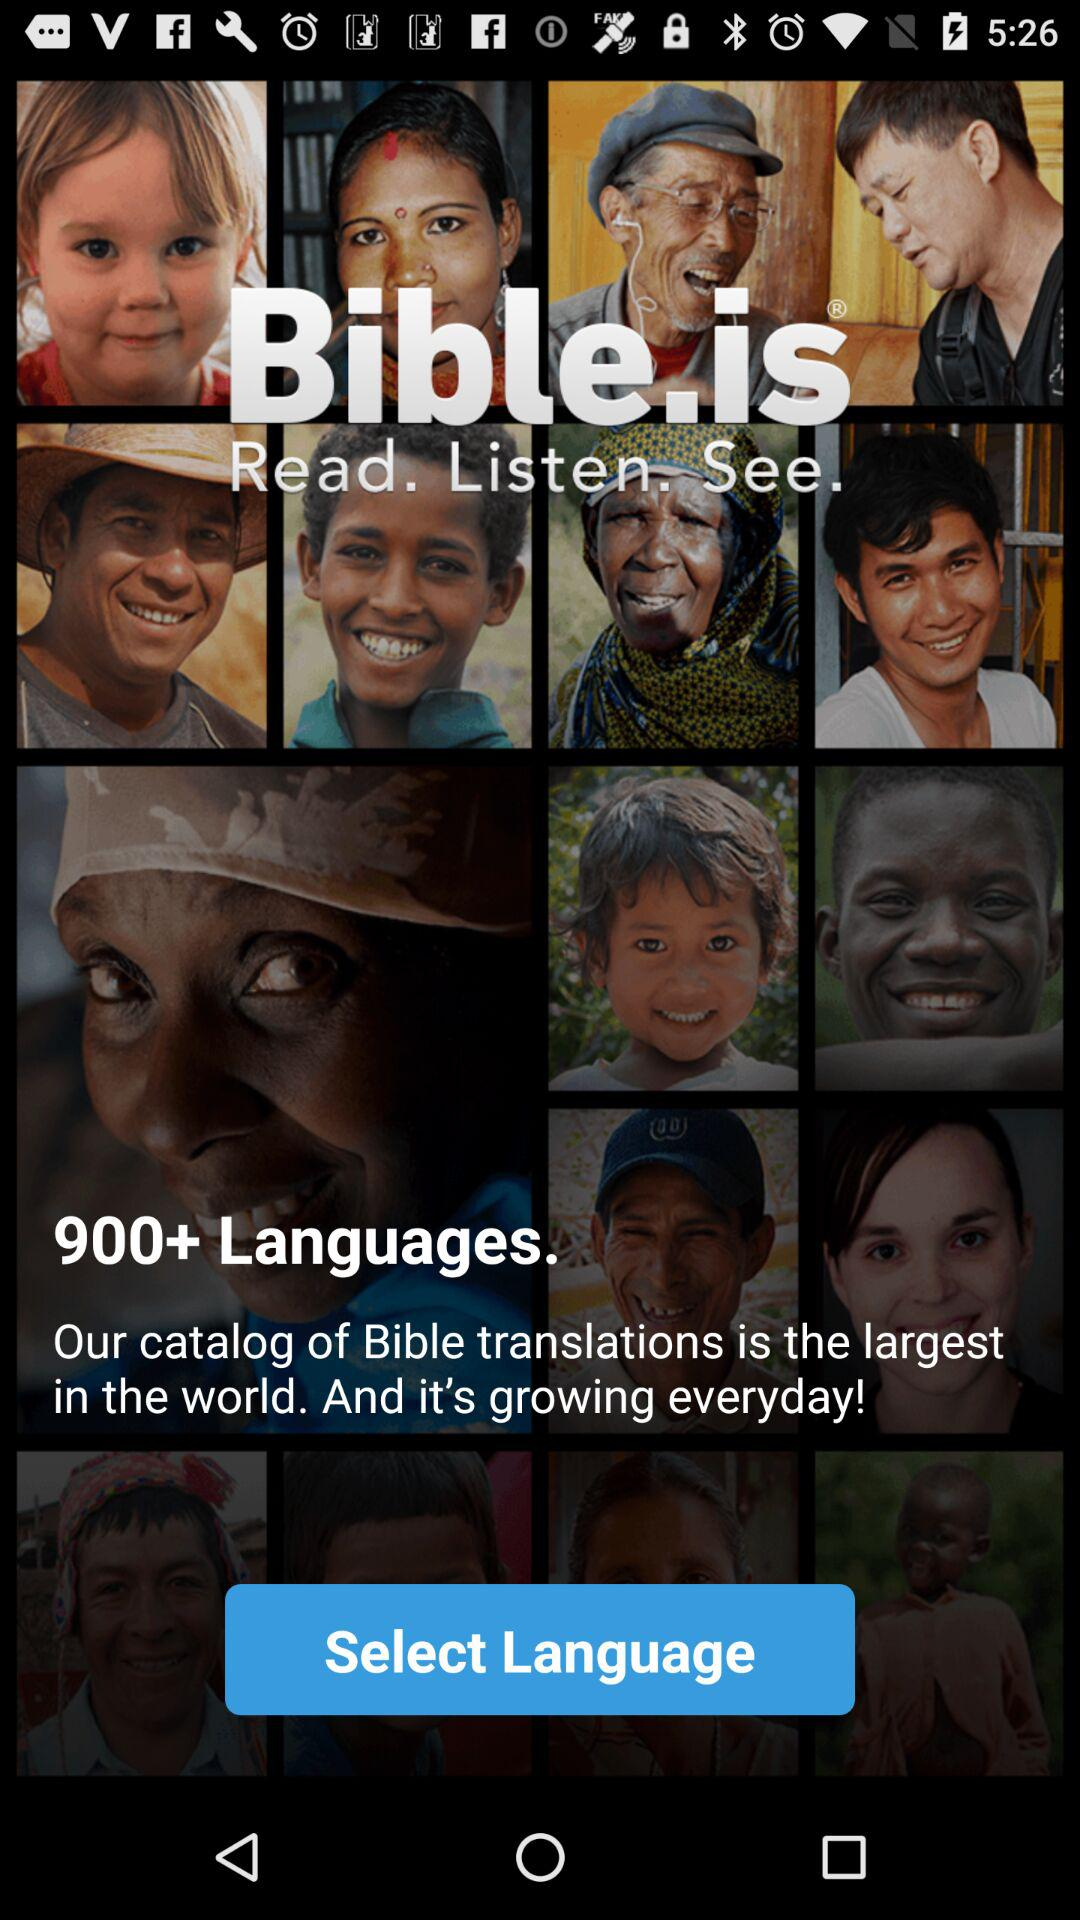In how many languages is the Bible translated? The Bible is translated into more than 900 languages. 